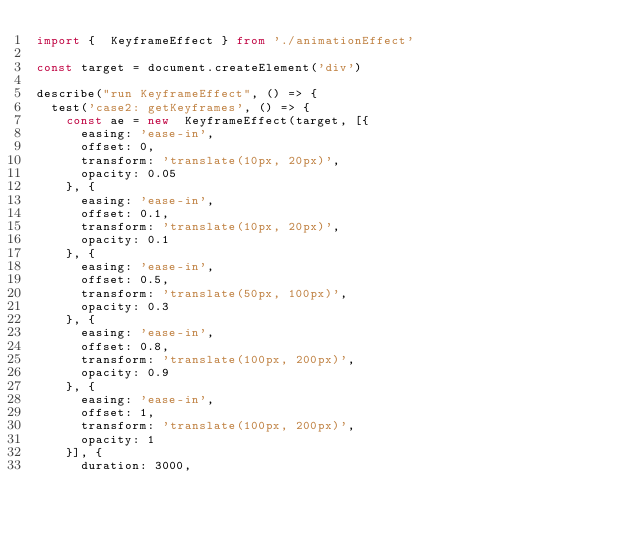Convert code to text. <code><loc_0><loc_0><loc_500><loc_500><_TypeScript_>import {  KeyframeEffect } from './animationEffect'

const target = document.createElement('div')

describe("run KeyframeEffect", () => {
  test('case2: getKeyframes', () => {
    const ae = new  KeyframeEffect(target, [{
      easing: 'ease-in',
      offset: 0,
      transform: 'translate(10px, 20px)',
      opacity: 0.05
    }, {
      easing: 'ease-in',
      offset: 0.1,
      transform: 'translate(10px, 20px)',
      opacity: 0.1
    }, {
      easing: 'ease-in',
      offset: 0.5,
      transform: 'translate(50px, 100px)',
      opacity: 0.3
    }, {
      easing: 'ease-in',
      offset: 0.8,
      transform: 'translate(100px, 200px)',
      opacity: 0.9
    }, {
      easing: 'ease-in',
      offset: 1,
      transform: 'translate(100px, 200px)',
      opacity: 1
    }], {
      duration: 3000,</code> 